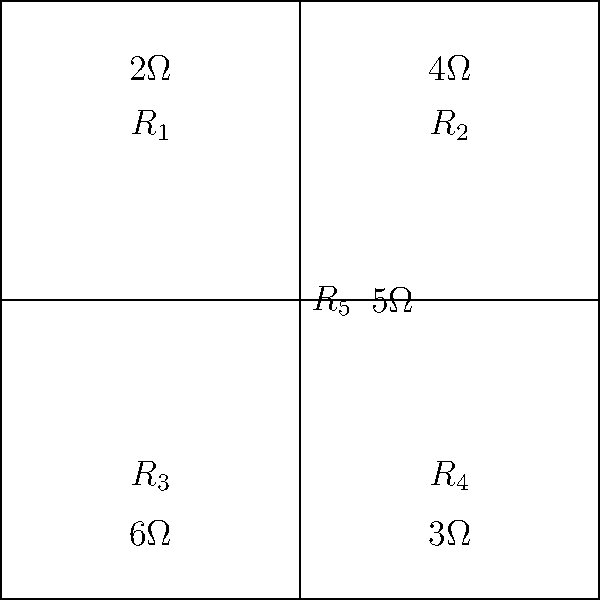As a biochemist working on optimizing laboratory equipment, you encounter a circuit diagram representing a critical component in a spectrophotometer. Given the resistor values shown in the circuit, calculate the equivalent resistance between points A and B. How might understanding this circuit's behavior contribute to improving the spectrophotometer's sensitivity for analyzing biochemical samples? To solve this problem, we'll use a step-by-step approach:

1) First, identify the circuit configuration. This is a bridge circuit with a cross-connection (R5).

2) To simplify, we can break this into two parts:
   a) The upper and lower parallel combinations
   b) The middle resistor (R5)

3) Calculate the upper parallel combination (R1 || R2):
   $$R_{top} = \frac{1}{\frac{1}{R_1} + \frac{1}{R_2}} = \frac{1}{\frac{1}{2} + \frac{1}{4}} = \frac{4}{3}\Omega$$

4) Calculate the lower parallel combination (R3 || R4):
   $$R_{bottom} = \frac{1}{\frac{1}{R_3} + \frac{1}{R_4}} = \frac{1}{\frac{1}{6} + \frac{1}{3}} = 2\Omega$$

5) Now we have a series-parallel combination:
   (R_top) || R5 || (R_bottom)

6) Calculate the equivalent resistance:
   $$R_{eq} = \frac{1}{\frac{1}{R_{top}} + \frac{1}{R_5} + \frac{1}{R_{bottom}}}$$
   $$R_{eq} = \frac{1}{\frac{3}{4} + \frac{1}{5} + \frac{1}{2}}$$
   $$R_{eq} = \frac{1}{\frac{15}{20} + \frac{4}{20} + \frac{10}{20}} = \frac{20}{29} \approx 0.69\Omega$$

Understanding this circuit's behavior could contribute to improving the spectrophotometer's sensitivity by:
1) Optimizing current flow through the light sensor
2) Minimizing noise in the electrical signal
3) Enhancing the precision of wavelength selection
4) Improving the overall signal-to-noise ratio for more accurate biochemical sample analysis
Answer: $R_{eq} = \frac{20}{29}\Omega \approx 0.69\Omega$ 